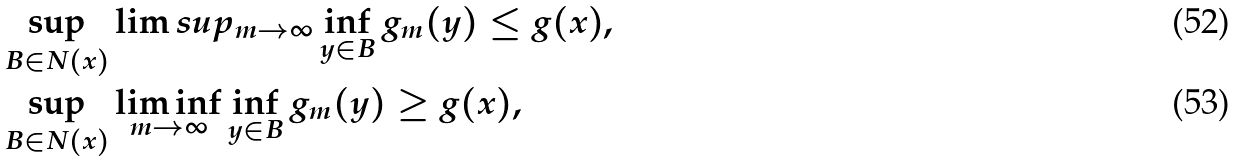<formula> <loc_0><loc_0><loc_500><loc_500>& \sup _ { B \in N ( x ) } \lim s u p _ { m \to \infty } \inf _ { y \in B } g _ { m } ( y ) \leq g ( x ) , \\ & \sup _ { B \in N ( x ) } \liminf _ { m \to \infty } \inf _ { y \in B } g _ { m } ( y ) \geq g ( x ) ,</formula> 